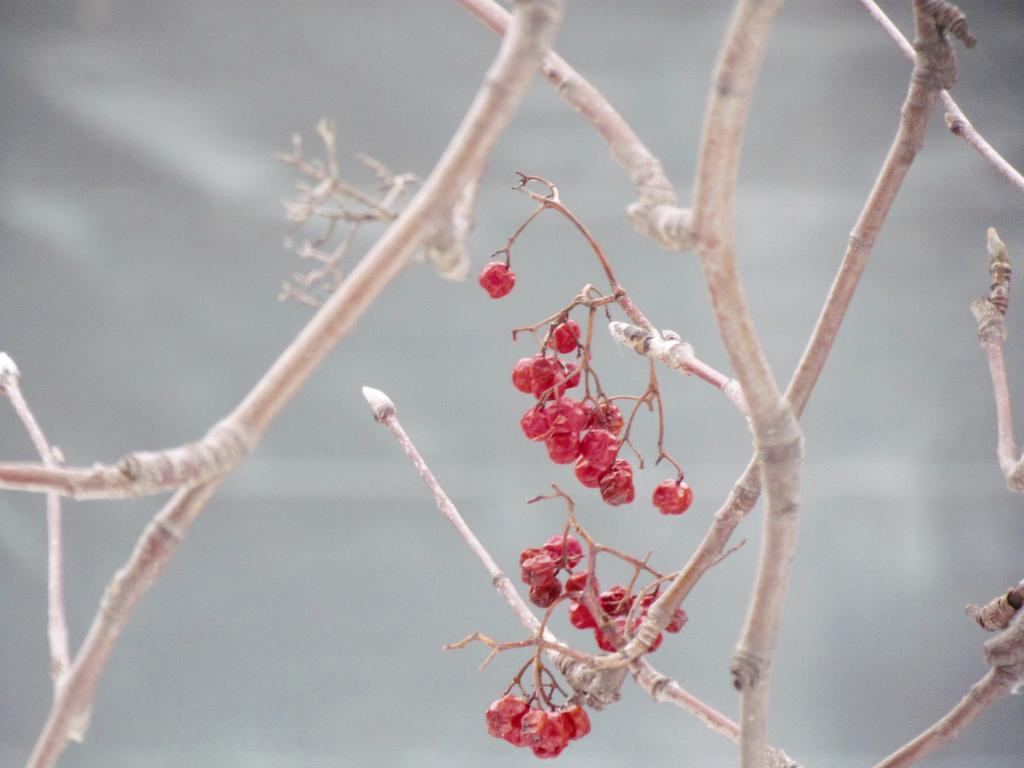What type of natural elements can be seen in the image? There are branches in the image. What else can be found on the branches? There are fruits in the image. Can you describe the background of the image? The background of the image is blurred. What type of doll is being read a fictional story in the image? There is no doll or reading activity present in the image; it features branches with fruits and a blurred background. 